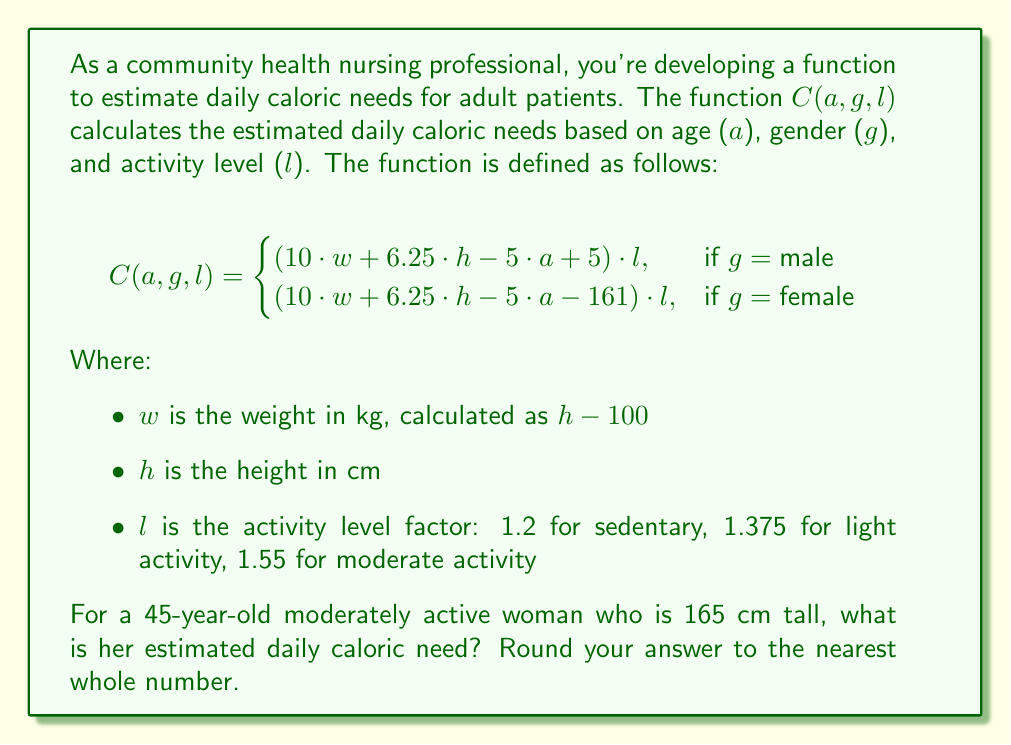Can you answer this question? Let's solve this problem step by step:

1) First, we identify the given information:
   - Age ($a$) = 45 years
   - Gender ($g$) = female
   - Height ($h$) = 165 cm
   - Activity level ($l$) = 1.55 (moderate activity)

2) We need to calculate the weight ($w$):
   $w = h - 100 = 165 - 100 = 65$ kg

3) Now we can use the female version of the function:
   $C(a, g, l) = (10 \cdot w + 6.25 \cdot h - 5 \cdot a - 161) \cdot l$

4) Let's substitute the values:
   $C(45, \text{female}, 1.55) = (10 \cdot 65 + 6.25 \cdot 165 - 5 \cdot 45 - 161) \cdot 1.55$

5) Let's calculate step by step:
   $= (650 + 1031.25 - 225 - 161) \cdot 1.55$
   $= 1295.25 \cdot 1.55$
   $= 2007.6375$

6) Rounding to the nearest whole number:
   2008 calories
Answer: 2008 calories 